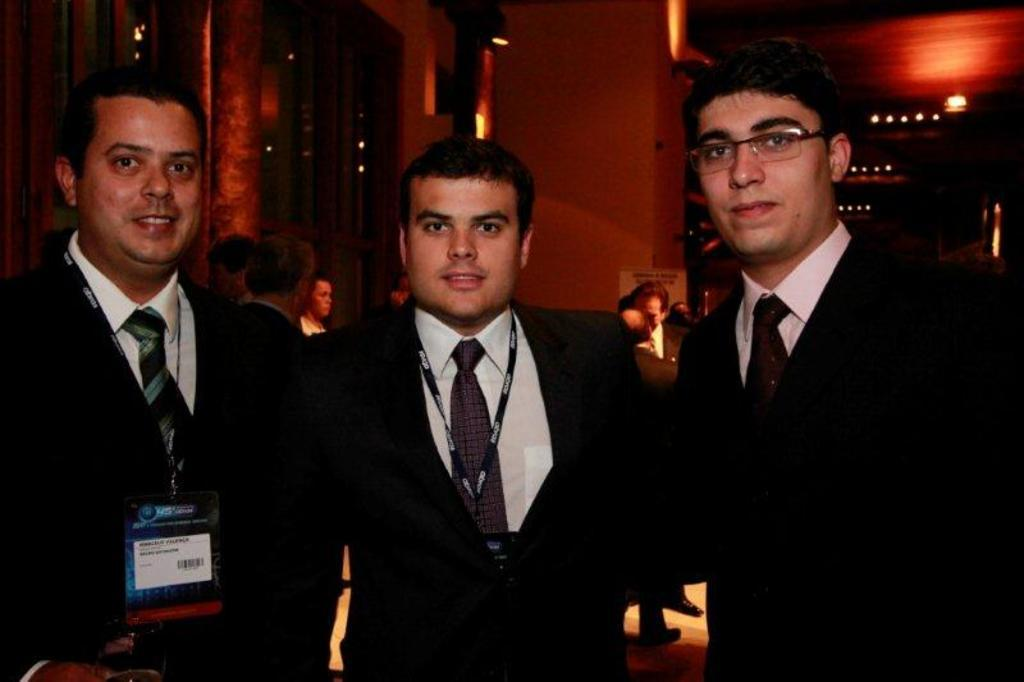How many people are standing in the image? There are three people standing in the image. What are the three people wearing? The three people are wearing black suits. Can you describe the background of the image? There are people and lights visible in the background of the image. What type of surprise can be seen in the pail in the image? There is no pail present in the image, and therefore no surprise can be seen. Is there a camera visible in the image? There is no camera visible in the image. 